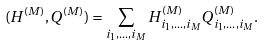Convert formula to latex. <formula><loc_0><loc_0><loc_500><loc_500>( H ^ { ( M ) } , Q ^ { ( M ) } ) = \sum _ { i _ { 1 } , \dots , i _ { M } } H _ { i _ { 1 } , \dots , i _ { M } } ^ { ( M ) } Q _ { i _ { 1 } , \dots , i _ { M } } ^ { ( M ) } .</formula> 